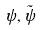<formula> <loc_0><loc_0><loc_500><loc_500>\psi , \tilde { \psi }</formula> 